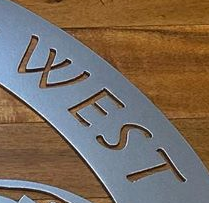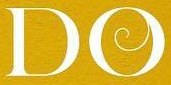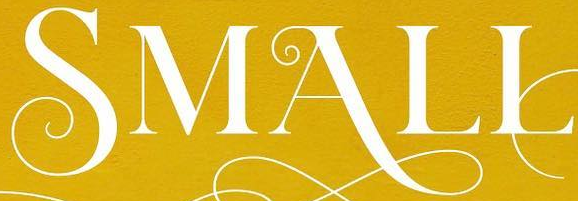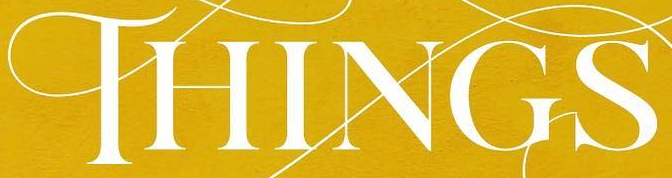Identify the words shown in these images in order, separated by a semicolon. WEST; DO; SMALL; THINGS 